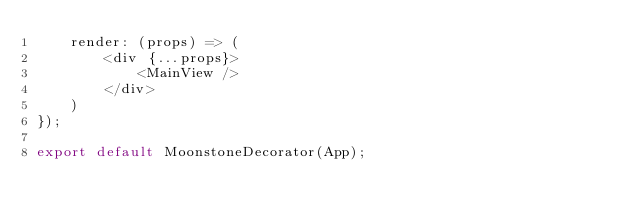Convert code to text. <code><loc_0><loc_0><loc_500><loc_500><_JavaScript_>	render: (props) => (
		<div {...props}>
			<MainView />
		</div>
	)
});

export default MoonstoneDecorator(App);
</code> 